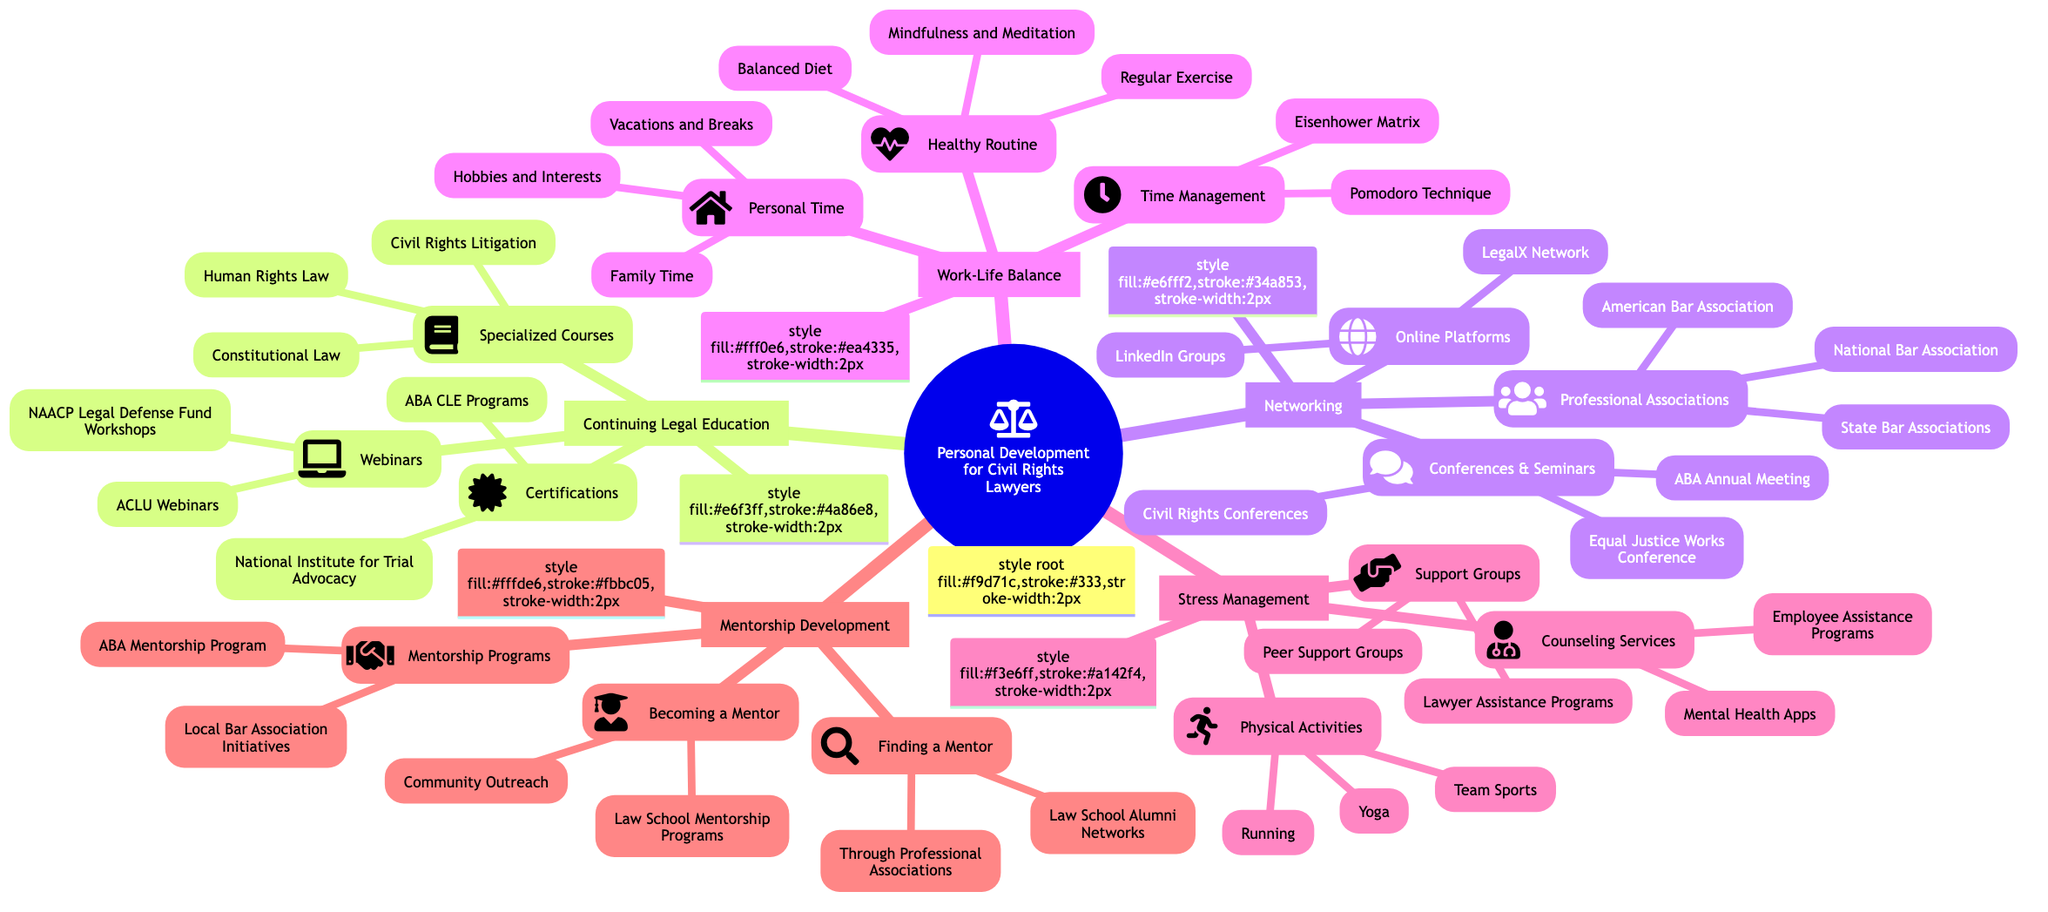What are two specialized courses listed under Continuing Legal Education? The diagram shows specialized courses listed under the Continuing Legal Education node, specifically Civil Rights Litigation and Constitutional Law.
Answer: Civil Rights Litigation, Constitutional Law How many main focus areas are identified in the personal development mind map? Counting the nodes that branch out from the main root node titled "Personal Development for Civil Rights Lawyers," there are five main focus areas: Continuing Legal Education, Networking, Work-Life Balance, Stress Management, and Mentorship Development.
Answer: 5 Which organization offers webinars mentioned in the Continuing Legal Education section? Under the Continuing Legal Education node, the ACLU Webinars and NAACP Legal Defense Fund Workshops are listed, indicating those organizations offer such webinars.
Answer: ACLU, NAACP What technique is mentioned in the Work-Life Balance section for time management? The Work-Life Balance node lists techniques for time management, specifically naming the Pomodoro Technique and the Eisenhower Matrix as examples.
Answer: Pomodoro Technique, Eisenhower Matrix Which physical activity is associated with stress management in the mind map? Within the Stress Management section, Yoga is explicitly mentioned as a physical activity to help manage stress, along with Running and Team Sports.
Answer: Yoga Which type of program is included in the Mentorship Development section for finding a mentor? The diagram details two avenues for finding a mentor under Mentorship Development: Through Professional Associations and Law School Alumni Networks, indicating those as appropriate programs.
Answer: Professional Associations, Law School Alumni Networks What is a support service listed under Stress Management for lawyers? The Stress Management node identifies Counseling Services as a category that includes Employee Assistance Programs, indicating support services specifically aimed at managing stress for lawyers.
Answer: Employee Assistance Programs How are Lawyers encouraged to participate in mentorship according to the diagram? In the Mentorship Development section, the diagram suggests two elements: Participating in Law School Mentorship Programs and Community Outreach, indicating active ways for lawyers to become mentors.
Answer: Law School Mentorship Programs, Community Outreach 